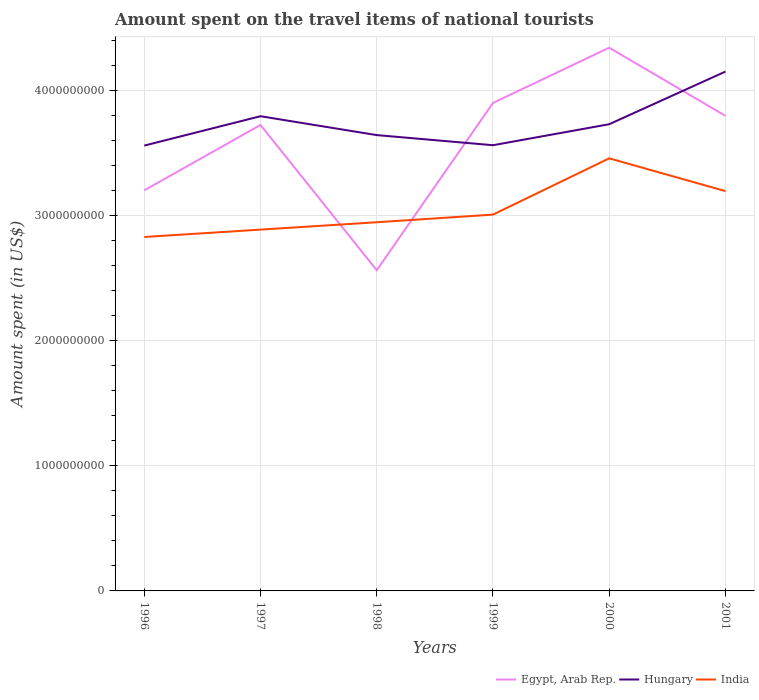Does the line corresponding to Egypt, Arab Rep. intersect with the line corresponding to India?
Make the answer very short. Yes. Across all years, what is the maximum amount spent on the travel items of national tourists in India?
Provide a short and direct response. 2.83e+09. In which year was the amount spent on the travel items of national tourists in Hungary maximum?
Make the answer very short. 1996. What is the total amount spent on the travel items of national tourists in Hungary in the graph?
Offer a very short reply. -8.40e+07. What is the difference between the highest and the second highest amount spent on the travel items of national tourists in Hungary?
Keep it short and to the point. 5.92e+08. Is the amount spent on the travel items of national tourists in Hungary strictly greater than the amount spent on the travel items of national tourists in Egypt, Arab Rep. over the years?
Keep it short and to the point. No. How many lines are there?
Provide a short and direct response. 3. How many years are there in the graph?
Your response must be concise. 6. What is the difference between two consecutive major ticks on the Y-axis?
Ensure brevity in your answer.  1.00e+09. Are the values on the major ticks of Y-axis written in scientific E-notation?
Offer a very short reply. No. Does the graph contain any zero values?
Your answer should be compact. No. Where does the legend appear in the graph?
Your answer should be compact. Bottom right. What is the title of the graph?
Ensure brevity in your answer.  Amount spent on the travel items of national tourists. Does "Lithuania" appear as one of the legend labels in the graph?
Make the answer very short. No. What is the label or title of the X-axis?
Your answer should be very brief. Years. What is the label or title of the Y-axis?
Give a very brief answer. Amount spent (in US$). What is the Amount spent (in US$) of Egypt, Arab Rep. in 1996?
Make the answer very short. 3.20e+09. What is the Amount spent (in US$) in Hungary in 1996?
Your answer should be compact. 3.56e+09. What is the Amount spent (in US$) of India in 1996?
Give a very brief answer. 2.83e+09. What is the Amount spent (in US$) in Egypt, Arab Rep. in 1997?
Your answer should be very brief. 3.73e+09. What is the Amount spent (in US$) in Hungary in 1997?
Offer a terse response. 3.80e+09. What is the Amount spent (in US$) in India in 1997?
Your response must be concise. 2.89e+09. What is the Amount spent (in US$) of Egypt, Arab Rep. in 1998?
Offer a terse response. 2.56e+09. What is the Amount spent (in US$) of Hungary in 1998?
Make the answer very short. 3.65e+09. What is the Amount spent (in US$) of India in 1998?
Your response must be concise. 2.95e+09. What is the Amount spent (in US$) of Egypt, Arab Rep. in 1999?
Your answer should be very brief. 3.90e+09. What is the Amount spent (in US$) in Hungary in 1999?
Offer a very short reply. 3.56e+09. What is the Amount spent (in US$) of India in 1999?
Offer a very short reply. 3.01e+09. What is the Amount spent (in US$) in Egypt, Arab Rep. in 2000?
Give a very brief answer. 4.34e+09. What is the Amount spent (in US$) in Hungary in 2000?
Make the answer very short. 3.73e+09. What is the Amount spent (in US$) in India in 2000?
Offer a very short reply. 3.46e+09. What is the Amount spent (in US$) in Egypt, Arab Rep. in 2001?
Make the answer very short. 3.80e+09. What is the Amount spent (in US$) of Hungary in 2001?
Keep it short and to the point. 4.15e+09. What is the Amount spent (in US$) of India in 2001?
Make the answer very short. 3.20e+09. Across all years, what is the maximum Amount spent (in US$) of Egypt, Arab Rep.?
Your response must be concise. 4.34e+09. Across all years, what is the maximum Amount spent (in US$) in Hungary?
Your answer should be very brief. 4.15e+09. Across all years, what is the maximum Amount spent (in US$) of India?
Keep it short and to the point. 3.46e+09. Across all years, what is the minimum Amount spent (in US$) of Egypt, Arab Rep.?
Offer a very short reply. 2.56e+09. Across all years, what is the minimum Amount spent (in US$) in Hungary?
Ensure brevity in your answer.  3.56e+09. Across all years, what is the minimum Amount spent (in US$) of India?
Your response must be concise. 2.83e+09. What is the total Amount spent (in US$) of Egypt, Arab Rep. in the graph?
Your response must be concise. 2.15e+1. What is the total Amount spent (in US$) of Hungary in the graph?
Make the answer very short. 2.25e+1. What is the total Amount spent (in US$) of India in the graph?
Your response must be concise. 1.83e+1. What is the difference between the Amount spent (in US$) in Egypt, Arab Rep. in 1996 and that in 1997?
Your answer should be compact. -5.23e+08. What is the difference between the Amount spent (in US$) of Hungary in 1996 and that in 1997?
Ensure brevity in your answer.  -2.35e+08. What is the difference between the Amount spent (in US$) in India in 1996 and that in 1997?
Offer a terse response. -5.90e+07. What is the difference between the Amount spent (in US$) in Egypt, Arab Rep. in 1996 and that in 1998?
Make the answer very short. 6.39e+08. What is the difference between the Amount spent (in US$) in Hungary in 1996 and that in 1998?
Provide a short and direct response. -8.40e+07. What is the difference between the Amount spent (in US$) in India in 1996 and that in 1998?
Make the answer very short. -1.18e+08. What is the difference between the Amount spent (in US$) in Egypt, Arab Rep. in 1996 and that in 1999?
Your answer should be very brief. -6.99e+08. What is the difference between the Amount spent (in US$) in Hungary in 1996 and that in 1999?
Offer a terse response. -3.00e+06. What is the difference between the Amount spent (in US$) of India in 1996 and that in 1999?
Provide a short and direct response. -1.79e+08. What is the difference between the Amount spent (in US$) of Egypt, Arab Rep. in 1996 and that in 2000?
Provide a short and direct response. -1.14e+09. What is the difference between the Amount spent (in US$) of Hungary in 1996 and that in 2000?
Make the answer very short. -1.71e+08. What is the difference between the Amount spent (in US$) in India in 1996 and that in 2000?
Offer a very short reply. -6.29e+08. What is the difference between the Amount spent (in US$) of Egypt, Arab Rep. in 1996 and that in 2001?
Ensure brevity in your answer.  -5.96e+08. What is the difference between the Amount spent (in US$) in Hungary in 1996 and that in 2001?
Give a very brief answer. -5.92e+08. What is the difference between the Amount spent (in US$) in India in 1996 and that in 2001?
Keep it short and to the point. -3.67e+08. What is the difference between the Amount spent (in US$) in Egypt, Arab Rep. in 1997 and that in 1998?
Your response must be concise. 1.16e+09. What is the difference between the Amount spent (in US$) in Hungary in 1997 and that in 1998?
Offer a terse response. 1.51e+08. What is the difference between the Amount spent (in US$) of India in 1997 and that in 1998?
Keep it short and to the point. -5.90e+07. What is the difference between the Amount spent (in US$) of Egypt, Arab Rep. in 1997 and that in 1999?
Offer a very short reply. -1.76e+08. What is the difference between the Amount spent (in US$) in Hungary in 1997 and that in 1999?
Provide a succinct answer. 2.32e+08. What is the difference between the Amount spent (in US$) of India in 1997 and that in 1999?
Give a very brief answer. -1.20e+08. What is the difference between the Amount spent (in US$) in Egypt, Arab Rep. in 1997 and that in 2000?
Your answer should be very brief. -6.18e+08. What is the difference between the Amount spent (in US$) in Hungary in 1997 and that in 2000?
Provide a short and direct response. 6.40e+07. What is the difference between the Amount spent (in US$) in India in 1997 and that in 2000?
Your answer should be very brief. -5.70e+08. What is the difference between the Amount spent (in US$) in Egypt, Arab Rep. in 1997 and that in 2001?
Your answer should be compact. -7.30e+07. What is the difference between the Amount spent (in US$) of Hungary in 1997 and that in 2001?
Your answer should be compact. -3.57e+08. What is the difference between the Amount spent (in US$) of India in 1997 and that in 2001?
Give a very brief answer. -3.08e+08. What is the difference between the Amount spent (in US$) in Egypt, Arab Rep. in 1998 and that in 1999?
Your answer should be compact. -1.34e+09. What is the difference between the Amount spent (in US$) of Hungary in 1998 and that in 1999?
Ensure brevity in your answer.  8.10e+07. What is the difference between the Amount spent (in US$) in India in 1998 and that in 1999?
Give a very brief answer. -6.10e+07. What is the difference between the Amount spent (in US$) in Egypt, Arab Rep. in 1998 and that in 2000?
Provide a succinct answer. -1.78e+09. What is the difference between the Amount spent (in US$) in Hungary in 1998 and that in 2000?
Provide a succinct answer. -8.70e+07. What is the difference between the Amount spent (in US$) in India in 1998 and that in 2000?
Give a very brief answer. -5.11e+08. What is the difference between the Amount spent (in US$) in Egypt, Arab Rep. in 1998 and that in 2001?
Your answer should be very brief. -1.24e+09. What is the difference between the Amount spent (in US$) in Hungary in 1998 and that in 2001?
Give a very brief answer. -5.08e+08. What is the difference between the Amount spent (in US$) in India in 1998 and that in 2001?
Your response must be concise. -2.49e+08. What is the difference between the Amount spent (in US$) in Egypt, Arab Rep. in 1999 and that in 2000?
Provide a short and direct response. -4.42e+08. What is the difference between the Amount spent (in US$) in Hungary in 1999 and that in 2000?
Provide a succinct answer. -1.68e+08. What is the difference between the Amount spent (in US$) in India in 1999 and that in 2000?
Ensure brevity in your answer.  -4.50e+08. What is the difference between the Amount spent (in US$) of Egypt, Arab Rep. in 1999 and that in 2001?
Offer a very short reply. 1.03e+08. What is the difference between the Amount spent (in US$) in Hungary in 1999 and that in 2001?
Offer a very short reply. -5.89e+08. What is the difference between the Amount spent (in US$) of India in 1999 and that in 2001?
Your answer should be very brief. -1.88e+08. What is the difference between the Amount spent (in US$) in Egypt, Arab Rep. in 2000 and that in 2001?
Your answer should be very brief. 5.45e+08. What is the difference between the Amount spent (in US$) of Hungary in 2000 and that in 2001?
Ensure brevity in your answer.  -4.21e+08. What is the difference between the Amount spent (in US$) of India in 2000 and that in 2001?
Your response must be concise. 2.62e+08. What is the difference between the Amount spent (in US$) of Egypt, Arab Rep. in 1996 and the Amount spent (in US$) of Hungary in 1997?
Your response must be concise. -5.93e+08. What is the difference between the Amount spent (in US$) of Egypt, Arab Rep. in 1996 and the Amount spent (in US$) of India in 1997?
Your answer should be compact. 3.14e+08. What is the difference between the Amount spent (in US$) in Hungary in 1996 and the Amount spent (in US$) in India in 1997?
Provide a short and direct response. 6.72e+08. What is the difference between the Amount spent (in US$) of Egypt, Arab Rep. in 1996 and the Amount spent (in US$) of Hungary in 1998?
Offer a very short reply. -4.42e+08. What is the difference between the Amount spent (in US$) of Egypt, Arab Rep. in 1996 and the Amount spent (in US$) of India in 1998?
Provide a succinct answer. 2.55e+08. What is the difference between the Amount spent (in US$) of Hungary in 1996 and the Amount spent (in US$) of India in 1998?
Your answer should be very brief. 6.13e+08. What is the difference between the Amount spent (in US$) of Egypt, Arab Rep. in 1996 and the Amount spent (in US$) of Hungary in 1999?
Keep it short and to the point. -3.61e+08. What is the difference between the Amount spent (in US$) in Egypt, Arab Rep. in 1996 and the Amount spent (in US$) in India in 1999?
Make the answer very short. 1.94e+08. What is the difference between the Amount spent (in US$) of Hungary in 1996 and the Amount spent (in US$) of India in 1999?
Ensure brevity in your answer.  5.52e+08. What is the difference between the Amount spent (in US$) in Egypt, Arab Rep. in 1996 and the Amount spent (in US$) in Hungary in 2000?
Provide a succinct answer. -5.29e+08. What is the difference between the Amount spent (in US$) in Egypt, Arab Rep. in 1996 and the Amount spent (in US$) in India in 2000?
Provide a succinct answer. -2.56e+08. What is the difference between the Amount spent (in US$) of Hungary in 1996 and the Amount spent (in US$) of India in 2000?
Your answer should be very brief. 1.02e+08. What is the difference between the Amount spent (in US$) of Egypt, Arab Rep. in 1996 and the Amount spent (in US$) of Hungary in 2001?
Give a very brief answer. -9.50e+08. What is the difference between the Amount spent (in US$) of Hungary in 1996 and the Amount spent (in US$) of India in 2001?
Keep it short and to the point. 3.64e+08. What is the difference between the Amount spent (in US$) of Egypt, Arab Rep. in 1997 and the Amount spent (in US$) of Hungary in 1998?
Your answer should be very brief. 8.10e+07. What is the difference between the Amount spent (in US$) of Egypt, Arab Rep. in 1997 and the Amount spent (in US$) of India in 1998?
Your answer should be very brief. 7.78e+08. What is the difference between the Amount spent (in US$) of Hungary in 1997 and the Amount spent (in US$) of India in 1998?
Provide a succinct answer. 8.48e+08. What is the difference between the Amount spent (in US$) in Egypt, Arab Rep. in 1997 and the Amount spent (in US$) in Hungary in 1999?
Keep it short and to the point. 1.62e+08. What is the difference between the Amount spent (in US$) of Egypt, Arab Rep. in 1997 and the Amount spent (in US$) of India in 1999?
Give a very brief answer. 7.17e+08. What is the difference between the Amount spent (in US$) in Hungary in 1997 and the Amount spent (in US$) in India in 1999?
Make the answer very short. 7.87e+08. What is the difference between the Amount spent (in US$) in Egypt, Arab Rep. in 1997 and the Amount spent (in US$) in Hungary in 2000?
Offer a very short reply. -6.00e+06. What is the difference between the Amount spent (in US$) of Egypt, Arab Rep. in 1997 and the Amount spent (in US$) of India in 2000?
Your answer should be very brief. 2.67e+08. What is the difference between the Amount spent (in US$) in Hungary in 1997 and the Amount spent (in US$) in India in 2000?
Keep it short and to the point. 3.37e+08. What is the difference between the Amount spent (in US$) in Egypt, Arab Rep. in 1997 and the Amount spent (in US$) in Hungary in 2001?
Offer a very short reply. -4.27e+08. What is the difference between the Amount spent (in US$) of Egypt, Arab Rep. in 1997 and the Amount spent (in US$) of India in 2001?
Provide a short and direct response. 5.29e+08. What is the difference between the Amount spent (in US$) in Hungary in 1997 and the Amount spent (in US$) in India in 2001?
Provide a short and direct response. 5.99e+08. What is the difference between the Amount spent (in US$) in Egypt, Arab Rep. in 1998 and the Amount spent (in US$) in Hungary in 1999?
Offer a very short reply. -1.00e+09. What is the difference between the Amount spent (in US$) of Egypt, Arab Rep. in 1998 and the Amount spent (in US$) of India in 1999?
Your answer should be very brief. -4.45e+08. What is the difference between the Amount spent (in US$) in Hungary in 1998 and the Amount spent (in US$) in India in 1999?
Give a very brief answer. 6.36e+08. What is the difference between the Amount spent (in US$) of Egypt, Arab Rep. in 1998 and the Amount spent (in US$) of Hungary in 2000?
Offer a terse response. -1.17e+09. What is the difference between the Amount spent (in US$) of Egypt, Arab Rep. in 1998 and the Amount spent (in US$) of India in 2000?
Offer a very short reply. -8.95e+08. What is the difference between the Amount spent (in US$) of Hungary in 1998 and the Amount spent (in US$) of India in 2000?
Your response must be concise. 1.86e+08. What is the difference between the Amount spent (in US$) of Egypt, Arab Rep. in 1998 and the Amount spent (in US$) of Hungary in 2001?
Your response must be concise. -1.59e+09. What is the difference between the Amount spent (in US$) of Egypt, Arab Rep. in 1998 and the Amount spent (in US$) of India in 2001?
Your response must be concise. -6.33e+08. What is the difference between the Amount spent (in US$) in Hungary in 1998 and the Amount spent (in US$) in India in 2001?
Your answer should be very brief. 4.48e+08. What is the difference between the Amount spent (in US$) in Egypt, Arab Rep. in 1999 and the Amount spent (in US$) in Hungary in 2000?
Offer a terse response. 1.70e+08. What is the difference between the Amount spent (in US$) in Egypt, Arab Rep. in 1999 and the Amount spent (in US$) in India in 2000?
Keep it short and to the point. 4.43e+08. What is the difference between the Amount spent (in US$) of Hungary in 1999 and the Amount spent (in US$) of India in 2000?
Offer a very short reply. 1.05e+08. What is the difference between the Amount spent (in US$) in Egypt, Arab Rep. in 1999 and the Amount spent (in US$) in Hungary in 2001?
Offer a terse response. -2.51e+08. What is the difference between the Amount spent (in US$) in Egypt, Arab Rep. in 1999 and the Amount spent (in US$) in India in 2001?
Your answer should be very brief. 7.05e+08. What is the difference between the Amount spent (in US$) of Hungary in 1999 and the Amount spent (in US$) of India in 2001?
Offer a very short reply. 3.67e+08. What is the difference between the Amount spent (in US$) of Egypt, Arab Rep. in 2000 and the Amount spent (in US$) of Hungary in 2001?
Provide a succinct answer. 1.91e+08. What is the difference between the Amount spent (in US$) of Egypt, Arab Rep. in 2000 and the Amount spent (in US$) of India in 2001?
Make the answer very short. 1.15e+09. What is the difference between the Amount spent (in US$) of Hungary in 2000 and the Amount spent (in US$) of India in 2001?
Your response must be concise. 5.35e+08. What is the average Amount spent (in US$) of Egypt, Arab Rep. per year?
Give a very brief answer. 3.59e+09. What is the average Amount spent (in US$) in Hungary per year?
Your answer should be very brief. 3.74e+09. What is the average Amount spent (in US$) in India per year?
Offer a terse response. 3.06e+09. In the year 1996, what is the difference between the Amount spent (in US$) in Egypt, Arab Rep. and Amount spent (in US$) in Hungary?
Provide a succinct answer. -3.58e+08. In the year 1996, what is the difference between the Amount spent (in US$) in Egypt, Arab Rep. and Amount spent (in US$) in India?
Give a very brief answer. 3.73e+08. In the year 1996, what is the difference between the Amount spent (in US$) in Hungary and Amount spent (in US$) in India?
Make the answer very short. 7.31e+08. In the year 1997, what is the difference between the Amount spent (in US$) in Egypt, Arab Rep. and Amount spent (in US$) in Hungary?
Offer a terse response. -7.00e+07. In the year 1997, what is the difference between the Amount spent (in US$) in Egypt, Arab Rep. and Amount spent (in US$) in India?
Ensure brevity in your answer.  8.37e+08. In the year 1997, what is the difference between the Amount spent (in US$) in Hungary and Amount spent (in US$) in India?
Make the answer very short. 9.07e+08. In the year 1998, what is the difference between the Amount spent (in US$) in Egypt, Arab Rep. and Amount spent (in US$) in Hungary?
Make the answer very short. -1.08e+09. In the year 1998, what is the difference between the Amount spent (in US$) in Egypt, Arab Rep. and Amount spent (in US$) in India?
Your answer should be compact. -3.84e+08. In the year 1998, what is the difference between the Amount spent (in US$) in Hungary and Amount spent (in US$) in India?
Provide a succinct answer. 6.97e+08. In the year 1999, what is the difference between the Amount spent (in US$) in Egypt, Arab Rep. and Amount spent (in US$) in Hungary?
Provide a short and direct response. 3.38e+08. In the year 1999, what is the difference between the Amount spent (in US$) of Egypt, Arab Rep. and Amount spent (in US$) of India?
Offer a very short reply. 8.93e+08. In the year 1999, what is the difference between the Amount spent (in US$) in Hungary and Amount spent (in US$) in India?
Keep it short and to the point. 5.55e+08. In the year 2000, what is the difference between the Amount spent (in US$) in Egypt, Arab Rep. and Amount spent (in US$) in Hungary?
Your response must be concise. 6.12e+08. In the year 2000, what is the difference between the Amount spent (in US$) in Egypt, Arab Rep. and Amount spent (in US$) in India?
Provide a succinct answer. 8.85e+08. In the year 2000, what is the difference between the Amount spent (in US$) of Hungary and Amount spent (in US$) of India?
Your answer should be very brief. 2.73e+08. In the year 2001, what is the difference between the Amount spent (in US$) in Egypt, Arab Rep. and Amount spent (in US$) in Hungary?
Provide a short and direct response. -3.54e+08. In the year 2001, what is the difference between the Amount spent (in US$) in Egypt, Arab Rep. and Amount spent (in US$) in India?
Your answer should be very brief. 6.02e+08. In the year 2001, what is the difference between the Amount spent (in US$) of Hungary and Amount spent (in US$) of India?
Ensure brevity in your answer.  9.56e+08. What is the ratio of the Amount spent (in US$) in Egypt, Arab Rep. in 1996 to that in 1997?
Give a very brief answer. 0.86. What is the ratio of the Amount spent (in US$) in Hungary in 1996 to that in 1997?
Ensure brevity in your answer.  0.94. What is the ratio of the Amount spent (in US$) of India in 1996 to that in 1997?
Make the answer very short. 0.98. What is the ratio of the Amount spent (in US$) in Egypt, Arab Rep. in 1996 to that in 1998?
Ensure brevity in your answer.  1.25. What is the ratio of the Amount spent (in US$) in Hungary in 1996 to that in 1998?
Give a very brief answer. 0.98. What is the ratio of the Amount spent (in US$) of Egypt, Arab Rep. in 1996 to that in 1999?
Your answer should be very brief. 0.82. What is the ratio of the Amount spent (in US$) in India in 1996 to that in 1999?
Your response must be concise. 0.94. What is the ratio of the Amount spent (in US$) of Egypt, Arab Rep. in 1996 to that in 2000?
Provide a short and direct response. 0.74. What is the ratio of the Amount spent (in US$) of Hungary in 1996 to that in 2000?
Your answer should be very brief. 0.95. What is the ratio of the Amount spent (in US$) of India in 1996 to that in 2000?
Make the answer very short. 0.82. What is the ratio of the Amount spent (in US$) of Egypt, Arab Rep. in 1996 to that in 2001?
Make the answer very short. 0.84. What is the ratio of the Amount spent (in US$) in Hungary in 1996 to that in 2001?
Provide a succinct answer. 0.86. What is the ratio of the Amount spent (in US$) in India in 1996 to that in 2001?
Your answer should be compact. 0.89. What is the ratio of the Amount spent (in US$) of Egypt, Arab Rep. in 1997 to that in 1998?
Offer a very short reply. 1.45. What is the ratio of the Amount spent (in US$) of Hungary in 1997 to that in 1998?
Offer a terse response. 1.04. What is the ratio of the Amount spent (in US$) of Egypt, Arab Rep. in 1997 to that in 1999?
Give a very brief answer. 0.95. What is the ratio of the Amount spent (in US$) of Hungary in 1997 to that in 1999?
Ensure brevity in your answer.  1.07. What is the ratio of the Amount spent (in US$) of India in 1997 to that in 1999?
Keep it short and to the point. 0.96. What is the ratio of the Amount spent (in US$) in Egypt, Arab Rep. in 1997 to that in 2000?
Keep it short and to the point. 0.86. What is the ratio of the Amount spent (in US$) in Hungary in 1997 to that in 2000?
Give a very brief answer. 1.02. What is the ratio of the Amount spent (in US$) in India in 1997 to that in 2000?
Your answer should be very brief. 0.84. What is the ratio of the Amount spent (in US$) in Egypt, Arab Rep. in 1997 to that in 2001?
Provide a succinct answer. 0.98. What is the ratio of the Amount spent (in US$) of Hungary in 1997 to that in 2001?
Offer a very short reply. 0.91. What is the ratio of the Amount spent (in US$) of India in 1997 to that in 2001?
Ensure brevity in your answer.  0.9. What is the ratio of the Amount spent (in US$) in Egypt, Arab Rep. in 1998 to that in 1999?
Make the answer very short. 0.66. What is the ratio of the Amount spent (in US$) in Hungary in 1998 to that in 1999?
Offer a terse response. 1.02. What is the ratio of the Amount spent (in US$) in India in 1998 to that in 1999?
Keep it short and to the point. 0.98. What is the ratio of the Amount spent (in US$) in Egypt, Arab Rep. in 1998 to that in 2000?
Your answer should be very brief. 0.59. What is the ratio of the Amount spent (in US$) in Hungary in 1998 to that in 2000?
Ensure brevity in your answer.  0.98. What is the ratio of the Amount spent (in US$) in India in 1998 to that in 2000?
Give a very brief answer. 0.85. What is the ratio of the Amount spent (in US$) of Egypt, Arab Rep. in 1998 to that in 2001?
Your answer should be very brief. 0.68. What is the ratio of the Amount spent (in US$) of Hungary in 1998 to that in 2001?
Offer a terse response. 0.88. What is the ratio of the Amount spent (in US$) in India in 1998 to that in 2001?
Your answer should be compact. 0.92. What is the ratio of the Amount spent (in US$) of Egypt, Arab Rep. in 1999 to that in 2000?
Keep it short and to the point. 0.9. What is the ratio of the Amount spent (in US$) in Hungary in 1999 to that in 2000?
Offer a very short reply. 0.95. What is the ratio of the Amount spent (in US$) in India in 1999 to that in 2000?
Ensure brevity in your answer.  0.87. What is the ratio of the Amount spent (in US$) in Egypt, Arab Rep. in 1999 to that in 2001?
Give a very brief answer. 1.03. What is the ratio of the Amount spent (in US$) in Hungary in 1999 to that in 2001?
Offer a terse response. 0.86. What is the ratio of the Amount spent (in US$) in India in 1999 to that in 2001?
Make the answer very short. 0.94. What is the ratio of the Amount spent (in US$) in Egypt, Arab Rep. in 2000 to that in 2001?
Keep it short and to the point. 1.14. What is the ratio of the Amount spent (in US$) of Hungary in 2000 to that in 2001?
Your response must be concise. 0.9. What is the ratio of the Amount spent (in US$) in India in 2000 to that in 2001?
Provide a succinct answer. 1.08. What is the difference between the highest and the second highest Amount spent (in US$) of Egypt, Arab Rep.?
Ensure brevity in your answer.  4.42e+08. What is the difference between the highest and the second highest Amount spent (in US$) in Hungary?
Your response must be concise. 3.57e+08. What is the difference between the highest and the second highest Amount spent (in US$) in India?
Provide a succinct answer. 2.62e+08. What is the difference between the highest and the lowest Amount spent (in US$) of Egypt, Arab Rep.?
Your answer should be very brief. 1.78e+09. What is the difference between the highest and the lowest Amount spent (in US$) in Hungary?
Your answer should be compact. 5.92e+08. What is the difference between the highest and the lowest Amount spent (in US$) of India?
Keep it short and to the point. 6.29e+08. 